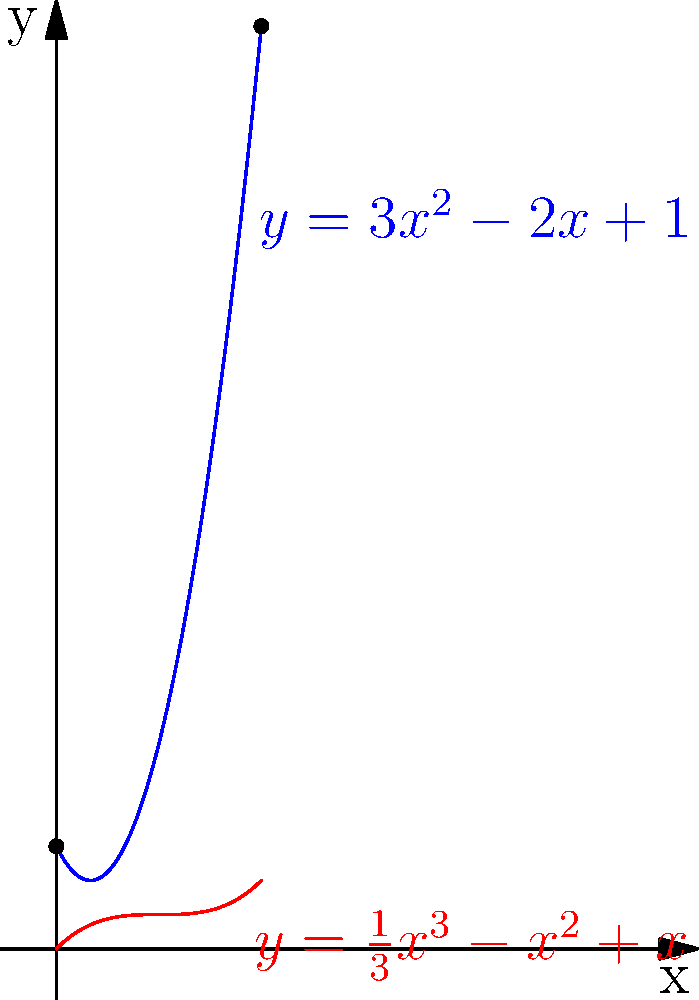As a food blogger experimenting with unique honey jars, you've designed a special container for your latest exotic honey flavor. The cross-sectional area of the jar at height $x$ cm is given by $A(x) = 3x^2 - 2x + 1$ cm². If the height of the jar is 2 cm, calculate the volume of honey it can hold. Use the method of polynomial integration and round your answer to the nearest 0.01 cm³. To find the volume of the honey jar, we need to integrate the cross-sectional area function over the height of the jar. Here's how we do it:

1) The volume is given by the integral:
   $$V = \int_0^2 A(x) dx = \int_0^2 (3x^2 - 2x + 1) dx$$

2) Integrate the polynomial term by term:
   $$V = \int_0^2 3x^2 dx - \int_0^2 2x dx + \int_0^2 1 dx$$

3) Apply the power rule of integration:
   $$V = [x^3]_0^2 - [x^2]_0^2 + [x]_0^2$$

4) Evaluate the definite integral:
   $$V = (2^3 - 0^3) - (2^2 - 0^2) + (2 - 0)$$

5) Simplify:
   $$V = 8 - 4 + 2 = 6$$

6) The volume is 6 cm³, which is already rounded to the nearest 0.01 cm³.

Therefore, the honey jar can hold 6 cm³ of honey.
Answer: 6 cm³ 